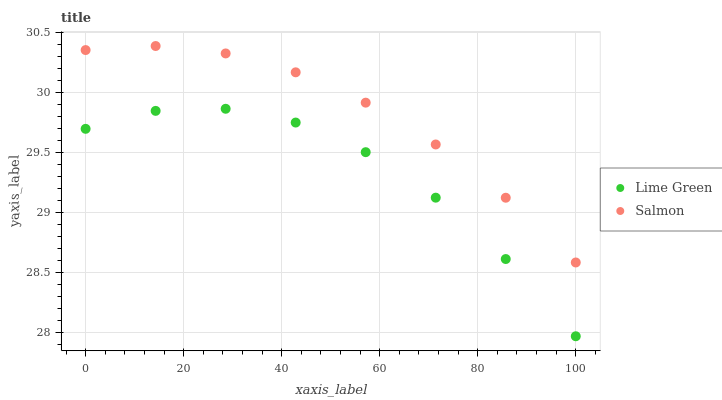Does Lime Green have the minimum area under the curve?
Answer yes or no. Yes. Does Salmon have the maximum area under the curve?
Answer yes or no. Yes. Does Lime Green have the maximum area under the curve?
Answer yes or no. No. Is Salmon the smoothest?
Answer yes or no. Yes. Is Lime Green the roughest?
Answer yes or no. Yes. Is Lime Green the smoothest?
Answer yes or no. No. Does Lime Green have the lowest value?
Answer yes or no. Yes. Does Salmon have the highest value?
Answer yes or no. Yes. Does Lime Green have the highest value?
Answer yes or no. No. Is Lime Green less than Salmon?
Answer yes or no. Yes. Is Salmon greater than Lime Green?
Answer yes or no. Yes. Does Lime Green intersect Salmon?
Answer yes or no. No. 